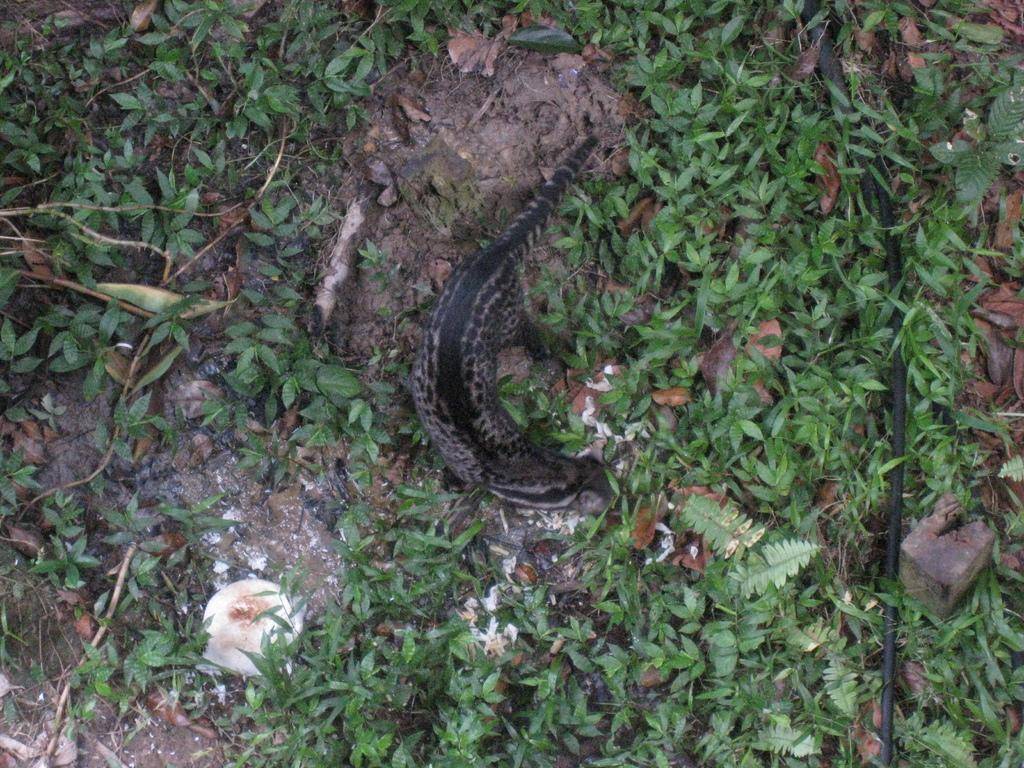What type of animal is in the image? There is an alligator lizard in the image. What is the alligator lizard resting on? The alligator lizard is on grass. Can you tell if the image was taken during the day or night? The image was likely taken during the day. What type of string is the alligator lizard lizard using to climb the mountain in the image? There is no mountain or string present in the image; it features an alligator lizard on grass. 